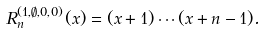<formula> <loc_0><loc_0><loc_500><loc_500>R _ { n } ^ { ( 1 , \emptyset , 0 , 0 ) } ( x ) = ( x + 1 ) \cdots ( x + n - 1 ) .</formula> 